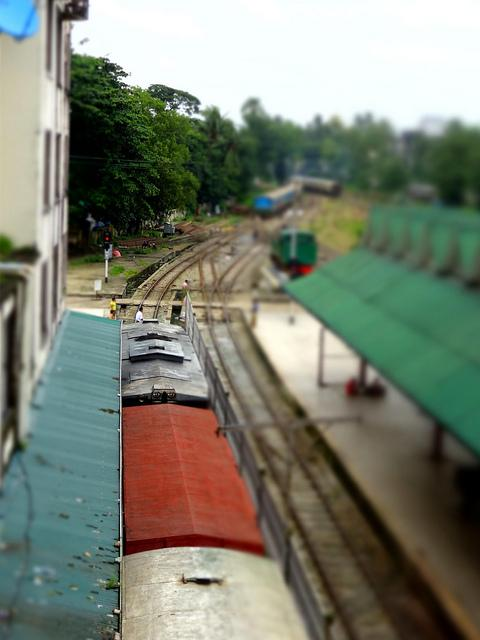Who works at one of these places? Please explain your reasoning. conductor. The conductor wroks. 